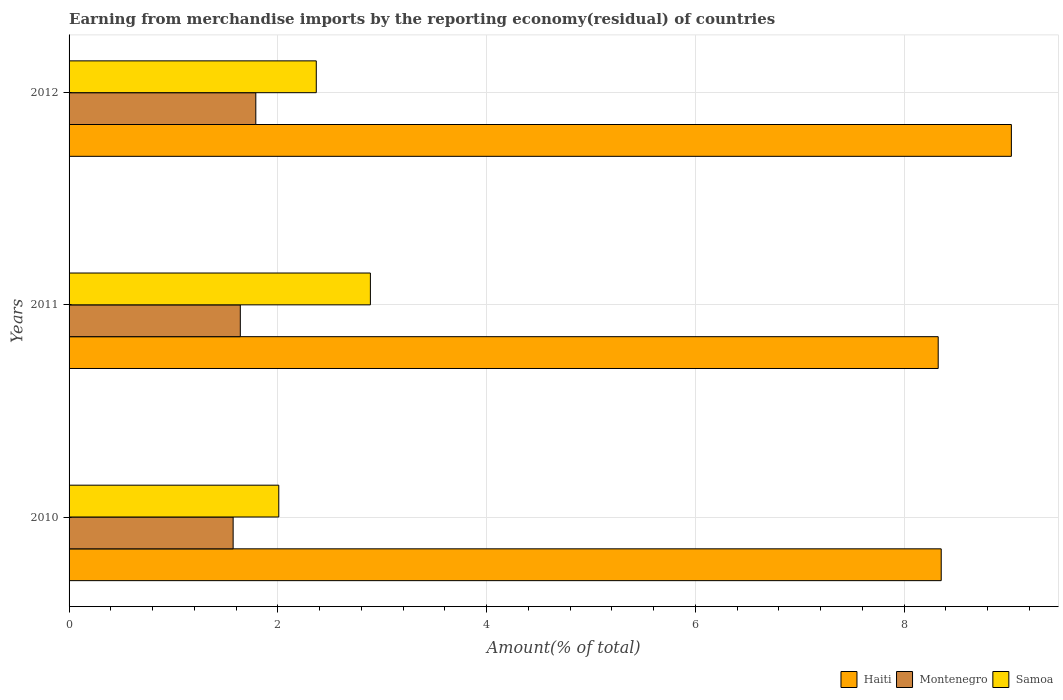How many different coloured bars are there?
Ensure brevity in your answer.  3. How many groups of bars are there?
Give a very brief answer. 3. Are the number of bars on each tick of the Y-axis equal?
Provide a short and direct response. Yes. How many bars are there on the 2nd tick from the top?
Your answer should be very brief. 3. What is the label of the 2nd group of bars from the top?
Give a very brief answer. 2011. What is the percentage of amount earned from merchandise imports in Montenegro in 2011?
Give a very brief answer. 1.64. Across all years, what is the maximum percentage of amount earned from merchandise imports in Samoa?
Your answer should be very brief. 2.89. Across all years, what is the minimum percentage of amount earned from merchandise imports in Samoa?
Your answer should be compact. 2.01. In which year was the percentage of amount earned from merchandise imports in Samoa maximum?
Make the answer very short. 2011. In which year was the percentage of amount earned from merchandise imports in Montenegro minimum?
Make the answer very short. 2010. What is the total percentage of amount earned from merchandise imports in Haiti in the graph?
Keep it short and to the point. 25.71. What is the difference between the percentage of amount earned from merchandise imports in Montenegro in 2011 and that in 2012?
Your response must be concise. -0.15. What is the difference between the percentage of amount earned from merchandise imports in Montenegro in 2011 and the percentage of amount earned from merchandise imports in Samoa in 2012?
Offer a terse response. -0.73. What is the average percentage of amount earned from merchandise imports in Haiti per year?
Offer a very short reply. 8.57. In the year 2011, what is the difference between the percentage of amount earned from merchandise imports in Samoa and percentage of amount earned from merchandise imports in Haiti?
Give a very brief answer. -5.44. In how many years, is the percentage of amount earned from merchandise imports in Samoa greater than 8 %?
Your response must be concise. 0. What is the ratio of the percentage of amount earned from merchandise imports in Haiti in 2011 to that in 2012?
Offer a terse response. 0.92. Is the percentage of amount earned from merchandise imports in Samoa in 2010 less than that in 2011?
Provide a short and direct response. Yes. Is the difference between the percentage of amount earned from merchandise imports in Samoa in 2010 and 2011 greater than the difference between the percentage of amount earned from merchandise imports in Haiti in 2010 and 2011?
Provide a succinct answer. No. What is the difference between the highest and the second highest percentage of amount earned from merchandise imports in Haiti?
Ensure brevity in your answer.  0.67. What is the difference between the highest and the lowest percentage of amount earned from merchandise imports in Haiti?
Offer a very short reply. 0.7. What does the 3rd bar from the top in 2012 represents?
Your answer should be very brief. Haiti. What does the 3rd bar from the bottom in 2012 represents?
Your response must be concise. Samoa. Is it the case that in every year, the sum of the percentage of amount earned from merchandise imports in Samoa and percentage of amount earned from merchandise imports in Haiti is greater than the percentage of amount earned from merchandise imports in Montenegro?
Provide a succinct answer. Yes. Are all the bars in the graph horizontal?
Provide a short and direct response. Yes. How many years are there in the graph?
Offer a terse response. 3. Are the values on the major ticks of X-axis written in scientific E-notation?
Give a very brief answer. No. Does the graph contain any zero values?
Your answer should be very brief. No. Where does the legend appear in the graph?
Offer a very short reply. Bottom right. How many legend labels are there?
Give a very brief answer. 3. What is the title of the graph?
Your answer should be compact. Earning from merchandise imports by the reporting economy(residual) of countries. What is the label or title of the X-axis?
Offer a very short reply. Amount(% of total). What is the label or title of the Y-axis?
Keep it short and to the point. Years. What is the Amount(% of total) in Haiti in 2010?
Give a very brief answer. 8.36. What is the Amount(% of total) in Montenegro in 2010?
Provide a short and direct response. 1.57. What is the Amount(% of total) of Samoa in 2010?
Offer a very short reply. 2.01. What is the Amount(% of total) in Haiti in 2011?
Make the answer very short. 8.33. What is the Amount(% of total) in Montenegro in 2011?
Give a very brief answer. 1.64. What is the Amount(% of total) in Samoa in 2011?
Keep it short and to the point. 2.89. What is the Amount(% of total) of Haiti in 2012?
Your answer should be very brief. 9.03. What is the Amount(% of total) in Montenegro in 2012?
Ensure brevity in your answer.  1.79. What is the Amount(% of total) in Samoa in 2012?
Your answer should be very brief. 2.37. Across all years, what is the maximum Amount(% of total) of Haiti?
Offer a very short reply. 9.03. Across all years, what is the maximum Amount(% of total) of Montenegro?
Offer a very short reply. 1.79. Across all years, what is the maximum Amount(% of total) in Samoa?
Make the answer very short. 2.89. Across all years, what is the minimum Amount(% of total) in Haiti?
Your answer should be very brief. 8.33. Across all years, what is the minimum Amount(% of total) of Montenegro?
Ensure brevity in your answer.  1.57. Across all years, what is the minimum Amount(% of total) of Samoa?
Your response must be concise. 2.01. What is the total Amount(% of total) of Haiti in the graph?
Keep it short and to the point. 25.71. What is the total Amount(% of total) of Montenegro in the graph?
Provide a succinct answer. 5. What is the total Amount(% of total) of Samoa in the graph?
Offer a very short reply. 7.26. What is the difference between the Amount(% of total) of Haiti in 2010 and that in 2011?
Your answer should be very brief. 0.03. What is the difference between the Amount(% of total) of Montenegro in 2010 and that in 2011?
Give a very brief answer. -0.07. What is the difference between the Amount(% of total) of Samoa in 2010 and that in 2011?
Offer a terse response. -0.88. What is the difference between the Amount(% of total) of Haiti in 2010 and that in 2012?
Offer a very short reply. -0.67. What is the difference between the Amount(% of total) in Montenegro in 2010 and that in 2012?
Provide a short and direct response. -0.22. What is the difference between the Amount(% of total) of Samoa in 2010 and that in 2012?
Make the answer very short. -0.36. What is the difference between the Amount(% of total) in Haiti in 2011 and that in 2012?
Provide a short and direct response. -0.7. What is the difference between the Amount(% of total) in Montenegro in 2011 and that in 2012?
Offer a very short reply. -0.15. What is the difference between the Amount(% of total) in Samoa in 2011 and that in 2012?
Offer a very short reply. 0.52. What is the difference between the Amount(% of total) in Haiti in 2010 and the Amount(% of total) in Montenegro in 2011?
Make the answer very short. 6.71. What is the difference between the Amount(% of total) of Haiti in 2010 and the Amount(% of total) of Samoa in 2011?
Your answer should be very brief. 5.47. What is the difference between the Amount(% of total) in Montenegro in 2010 and the Amount(% of total) in Samoa in 2011?
Keep it short and to the point. -1.31. What is the difference between the Amount(% of total) in Haiti in 2010 and the Amount(% of total) in Montenegro in 2012?
Make the answer very short. 6.57. What is the difference between the Amount(% of total) in Haiti in 2010 and the Amount(% of total) in Samoa in 2012?
Offer a terse response. 5.99. What is the difference between the Amount(% of total) of Montenegro in 2010 and the Amount(% of total) of Samoa in 2012?
Give a very brief answer. -0.8. What is the difference between the Amount(% of total) of Haiti in 2011 and the Amount(% of total) of Montenegro in 2012?
Your answer should be very brief. 6.54. What is the difference between the Amount(% of total) of Haiti in 2011 and the Amount(% of total) of Samoa in 2012?
Give a very brief answer. 5.96. What is the difference between the Amount(% of total) in Montenegro in 2011 and the Amount(% of total) in Samoa in 2012?
Provide a short and direct response. -0.73. What is the average Amount(% of total) in Haiti per year?
Your answer should be compact. 8.57. What is the average Amount(% of total) of Montenegro per year?
Provide a short and direct response. 1.67. What is the average Amount(% of total) of Samoa per year?
Offer a very short reply. 2.42. In the year 2010, what is the difference between the Amount(% of total) in Haiti and Amount(% of total) in Montenegro?
Give a very brief answer. 6.78. In the year 2010, what is the difference between the Amount(% of total) of Haiti and Amount(% of total) of Samoa?
Offer a very short reply. 6.35. In the year 2010, what is the difference between the Amount(% of total) in Montenegro and Amount(% of total) in Samoa?
Your answer should be very brief. -0.44. In the year 2011, what is the difference between the Amount(% of total) in Haiti and Amount(% of total) in Montenegro?
Give a very brief answer. 6.69. In the year 2011, what is the difference between the Amount(% of total) of Haiti and Amount(% of total) of Samoa?
Offer a terse response. 5.44. In the year 2011, what is the difference between the Amount(% of total) in Montenegro and Amount(% of total) in Samoa?
Offer a very short reply. -1.25. In the year 2012, what is the difference between the Amount(% of total) in Haiti and Amount(% of total) in Montenegro?
Make the answer very short. 7.24. In the year 2012, what is the difference between the Amount(% of total) in Haiti and Amount(% of total) in Samoa?
Make the answer very short. 6.66. In the year 2012, what is the difference between the Amount(% of total) in Montenegro and Amount(% of total) in Samoa?
Your answer should be very brief. -0.58. What is the ratio of the Amount(% of total) in Montenegro in 2010 to that in 2011?
Offer a terse response. 0.96. What is the ratio of the Amount(% of total) of Samoa in 2010 to that in 2011?
Provide a succinct answer. 0.7. What is the ratio of the Amount(% of total) of Haiti in 2010 to that in 2012?
Offer a terse response. 0.93. What is the ratio of the Amount(% of total) of Montenegro in 2010 to that in 2012?
Keep it short and to the point. 0.88. What is the ratio of the Amount(% of total) in Samoa in 2010 to that in 2012?
Provide a short and direct response. 0.85. What is the ratio of the Amount(% of total) in Haiti in 2011 to that in 2012?
Your answer should be very brief. 0.92. What is the ratio of the Amount(% of total) of Montenegro in 2011 to that in 2012?
Offer a very short reply. 0.92. What is the ratio of the Amount(% of total) in Samoa in 2011 to that in 2012?
Provide a succinct answer. 1.22. What is the difference between the highest and the second highest Amount(% of total) of Haiti?
Keep it short and to the point. 0.67. What is the difference between the highest and the second highest Amount(% of total) in Montenegro?
Keep it short and to the point. 0.15. What is the difference between the highest and the second highest Amount(% of total) in Samoa?
Ensure brevity in your answer.  0.52. What is the difference between the highest and the lowest Amount(% of total) of Haiti?
Make the answer very short. 0.7. What is the difference between the highest and the lowest Amount(% of total) of Montenegro?
Make the answer very short. 0.22. What is the difference between the highest and the lowest Amount(% of total) in Samoa?
Provide a succinct answer. 0.88. 